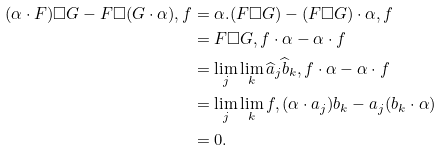<formula> <loc_0><loc_0><loc_500><loc_500>( \alpha \cdot F ) \square G - F \square ( G \cdot \alpha ) , f & = \alpha . ( F \square G ) - ( F \square G ) \cdot \alpha , f \\ & = F \square G , f \cdot \alpha - \alpha \cdot f \\ & = \lim _ { j } \lim _ { k } \widehat { a } _ { j } \widehat { b } _ { k } , f \cdot \alpha - \alpha \cdot f \\ & = \lim _ { j } \lim _ { k } f , ( \alpha \cdot a _ { j } ) b _ { k } - a _ { j } ( b _ { k } \cdot \alpha ) \\ & = 0 .</formula> 